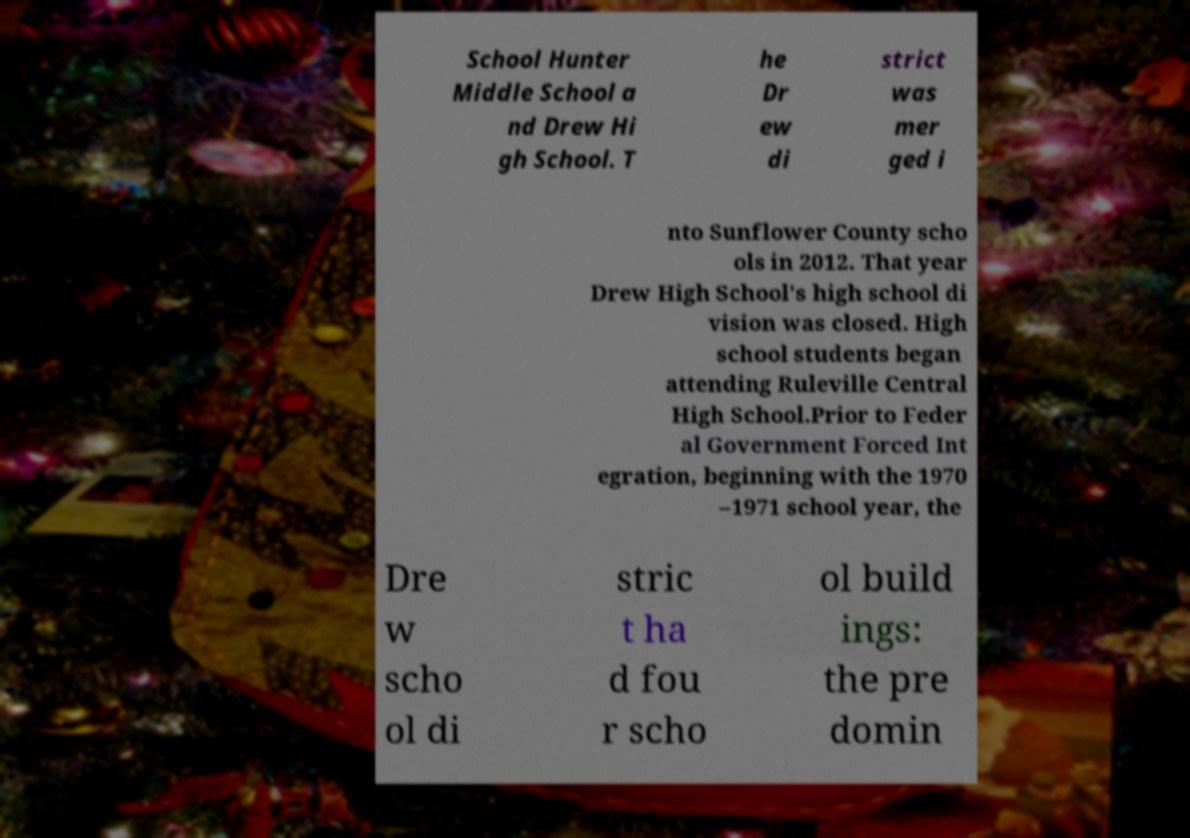For documentation purposes, I need the text within this image transcribed. Could you provide that? School Hunter Middle School a nd Drew Hi gh School. T he Dr ew di strict was mer ged i nto Sunflower County scho ols in 2012. That year Drew High School's high school di vision was closed. High school students began attending Ruleville Central High School.Prior to Feder al Government Forced Int egration, beginning with the 1970 –1971 school year, the Dre w scho ol di stric t ha d fou r scho ol build ings: the pre domin 